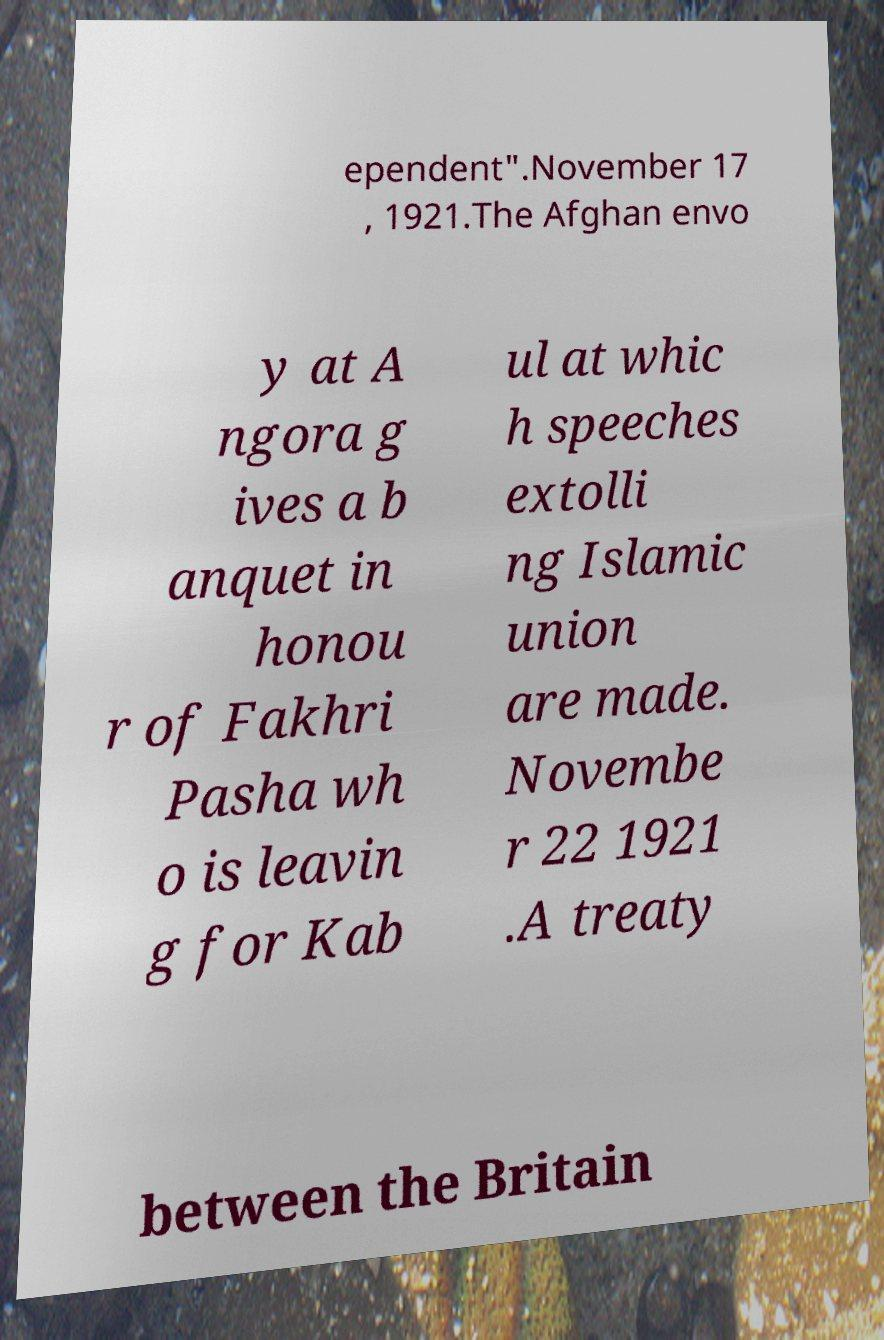Can you read and provide the text displayed in the image?This photo seems to have some interesting text. Can you extract and type it out for me? ependent".November 17 , 1921.The Afghan envo y at A ngora g ives a b anquet in honou r of Fakhri Pasha wh o is leavin g for Kab ul at whic h speeches extolli ng Islamic union are made. Novembe r 22 1921 .A treaty between the Britain 